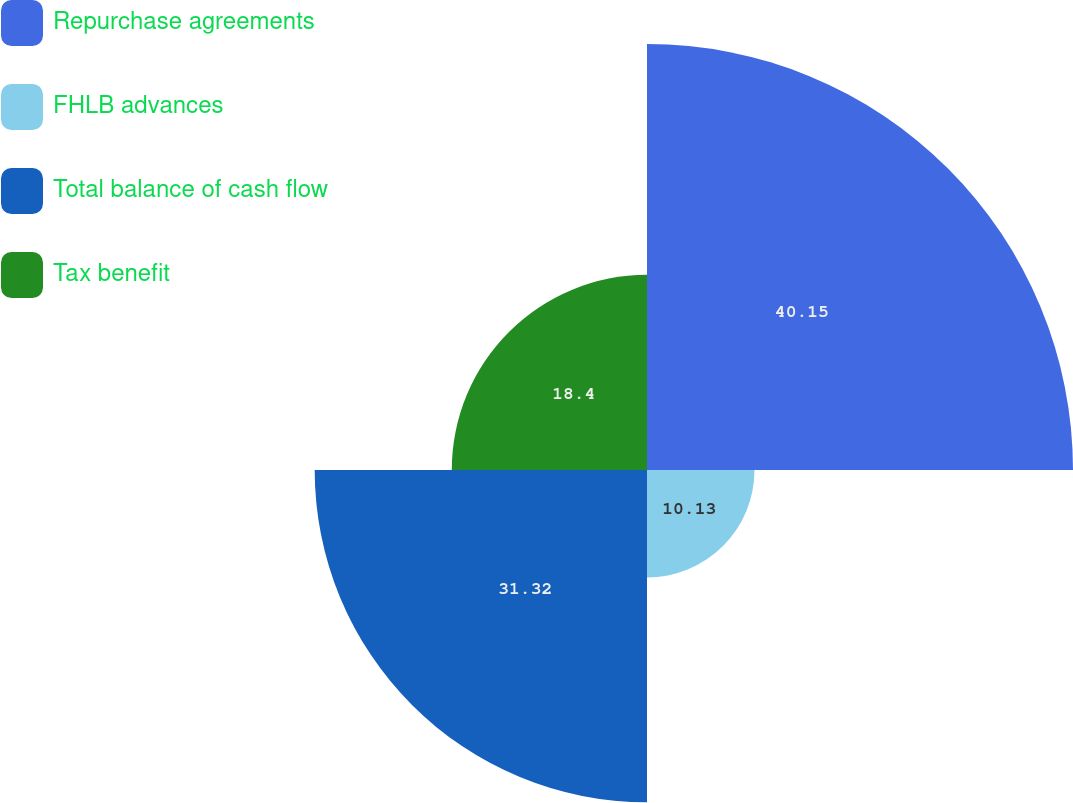<chart> <loc_0><loc_0><loc_500><loc_500><pie_chart><fcel>Repurchase agreements<fcel>FHLB advances<fcel>Total balance of cash flow<fcel>Tax benefit<nl><fcel>40.15%<fcel>10.13%<fcel>31.32%<fcel>18.4%<nl></chart> 